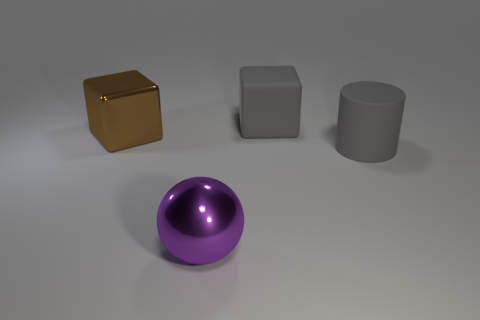Is there a matte cylinder that has the same size as the gray block? Upon close inspection of the image, there is indeed a matte cylinder presented to the right of the central sphere. The cylinder's height and diameter appear to visually match the dimensions of the gray block, suggesting they have the same size. 